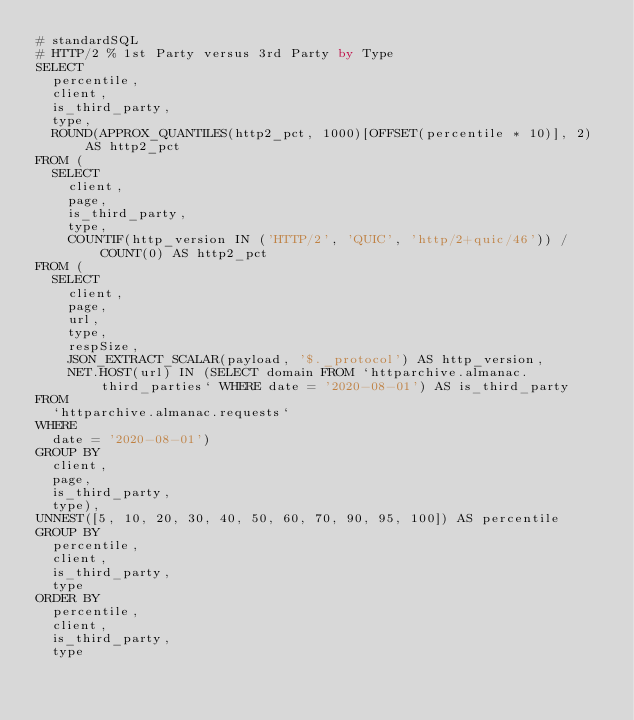Convert code to text. <code><loc_0><loc_0><loc_500><loc_500><_SQL_># standardSQL
# HTTP/2 % 1st Party versus 3rd Party by Type
SELECT
  percentile,
  client,
  is_third_party,
  type,
  ROUND(APPROX_QUANTILES(http2_pct, 1000)[OFFSET(percentile * 10)], 2) AS http2_pct
FROM (
  SELECT
    client,
    page,
    is_third_party,
    type,
    COUNTIF(http_version IN ('HTTP/2', 'QUIC', 'http/2+quic/46')) / COUNT(0) AS http2_pct
FROM (
  SELECT
    client,
    page,
    url,
    type,
    respSize,
    JSON_EXTRACT_SCALAR(payload, '$._protocol') AS http_version,
    NET.HOST(url) IN (SELECT domain FROM `httparchive.almanac.third_parties` WHERE date = '2020-08-01') AS is_third_party
FROM
  `httparchive.almanac.requests`
WHERE
  date = '2020-08-01')
GROUP BY
  client,
  page,
  is_third_party,
  type),
UNNEST([5, 10, 20, 30, 40, 50, 60, 70, 90, 95, 100]) AS percentile
GROUP BY
  percentile,
  client,
  is_third_party,
  type
ORDER BY
  percentile,
  client,
  is_third_party,
  type
</code> 